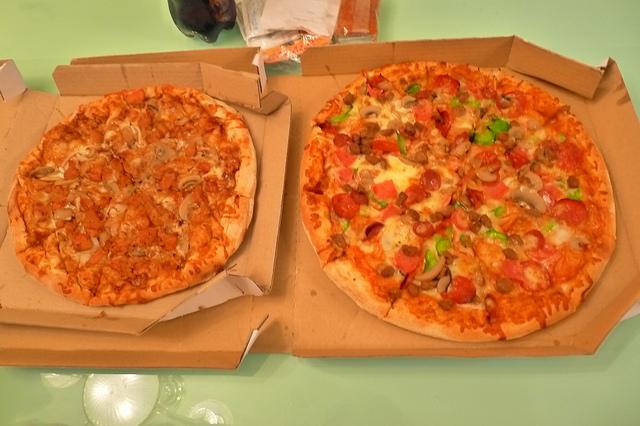What food type is shown?
Answer briefly. Pizza. Which pizza has more toppings?
Write a very short answer. Right. Do these pizza's look vegetarian?
Answer briefly. No. 